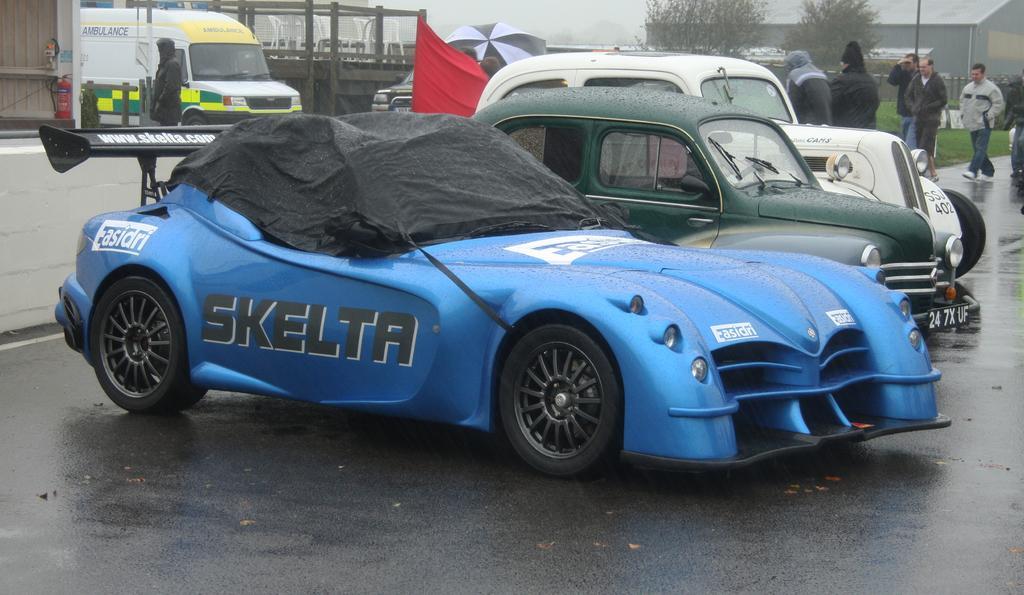Describe this image in one or two sentences. In this image there are cars on a road and people are walking, in the background there is a building, trees and houses. 